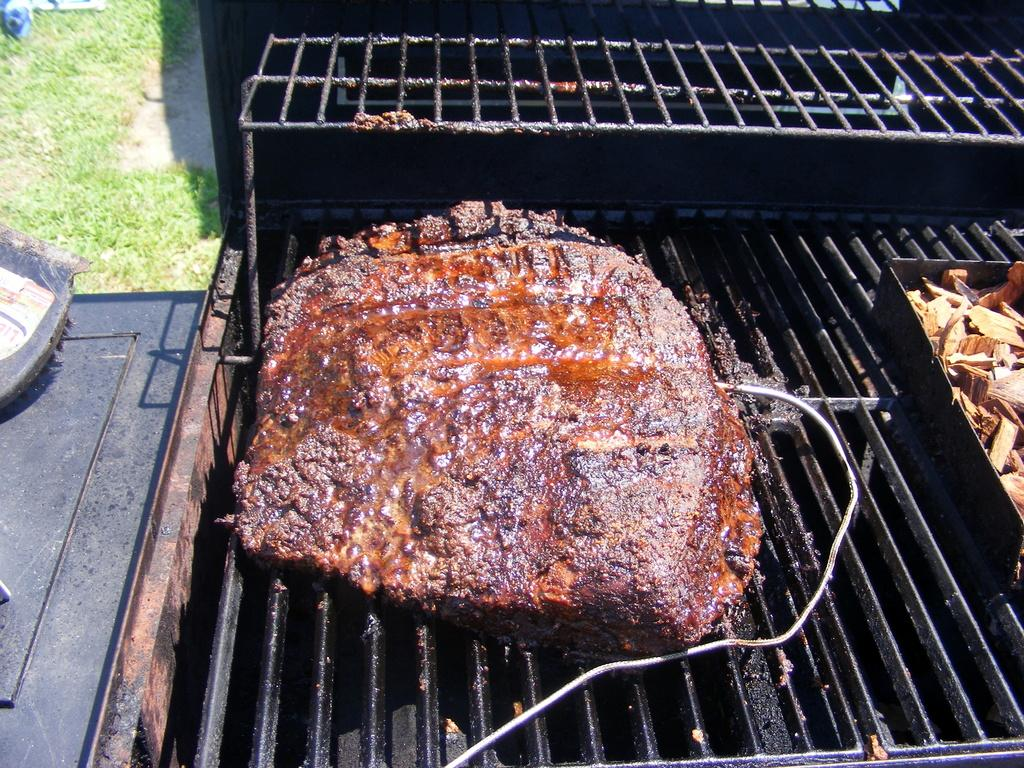What is being cooked on the grill stand in the image? There is a piece of meat on a grill stand in the image. What type of surface is the grill stand placed on? The ground is covered with grass in the image. What other objects can be seen in the image? There are other unspecified objects present beside the grill stand in the image. Is there a cap visible on the ground in the image? There is no mention of a cap in the image, so it cannot be determined if one is present. --- Facts: 1. There is a person holding a book in the image. 2. The person is sitting on a chair. 3. There is a table in front of the person. 4. The table has a cup on it. Absurd Topics: parrot, volcano, ocean Conversation: What is the person in the image holding? The person in the image is holding a book. What is the person's seating arrangement in the image? The person is sitting on a chair. What object is in front of the person? There is a table in front of the person. What can be seen on the table? The table has a cup on it. Reasoning: Let's think step by step in order to produce the conversation. We start by identifying the main subject in the image, which is the person holding a book. Then, we describe the person's seating arrangement, which is sitting on a chair. Next, we mention the presence of a table in front of the person. Finally, we identify the specific object on the table, which is a cup. Absurd Question/Answer: Can you see a volcano in the background of the image? There is no mention of a volcano in the image, so it cannot be determined if one is present. 